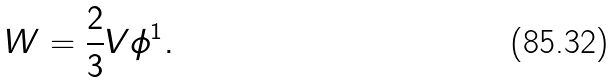<formula> <loc_0><loc_0><loc_500><loc_500>W = \frac { 2 } { 3 } V \phi ^ { 1 } .</formula> 